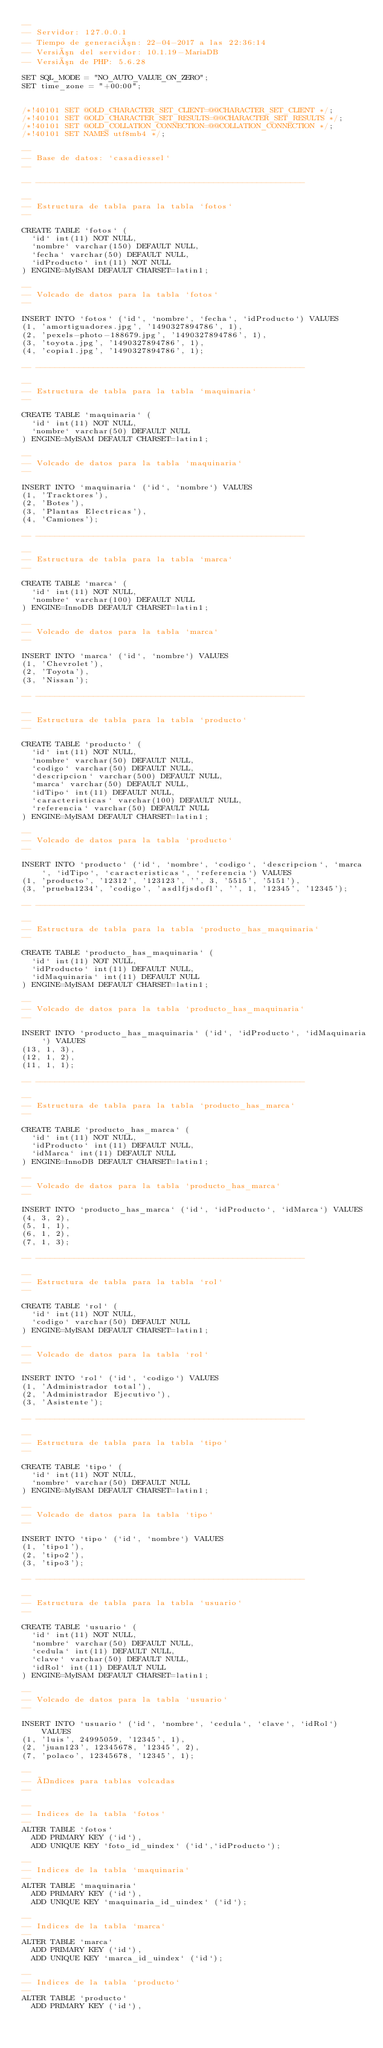<code> <loc_0><loc_0><loc_500><loc_500><_SQL_>--
-- Servidor: 127.0.0.1
-- Tiempo de generación: 22-04-2017 a las 22:36:14
-- Versión del servidor: 10.1.19-MariaDB
-- Versión de PHP: 5.6.28

SET SQL_MODE = "NO_AUTO_VALUE_ON_ZERO";
SET time_zone = "+00:00";


/*!40101 SET @OLD_CHARACTER_SET_CLIENT=@@CHARACTER_SET_CLIENT */;
/*!40101 SET @OLD_CHARACTER_SET_RESULTS=@@CHARACTER_SET_RESULTS */;
/*!40101 SET @OLD_COLLATION_CONNECTION=@@COLLATION_CONNECTION */;
/*!40101 SET NAMES utf8mb4 */;

--
-- Base de datos: `casadiessel`
--

-- --------------------------------------------------------

--
-- Estructura de tabla para la tabla `fotos`
--

CREATE TABLE `fotos` (
  `id` int(11) NOT NULL,
  `nombre` varchar(150) DEFAULT NULL,
  `fecha` varchar(50) DEFAULT NULL,
  `idProducto` int(11) NOT NULL
) ENGINE=MyISAM DEFAULT CHARSET=latin1;

--
-- Volcado de datos para la tabla `fotos`
--

INSERT INTO `fotos` (`id`, `nombre`, `fecha`, `idProducto`) VALUES
(1, 'amortiguadores.jpg', '1490327894786', 1),
(2, 'pexels-photo-188679.jpg', '1490327894786', 1),
(3, 'toyota.jpg', '1490327894786', 1),
(4, 'copia1.jpg', '1490327894786', 1);

-- --------------------------------------------------------

--
-- Estructura de tabla para la tabla `maquinaria`
--

CREATE TABLE `maquinaria` (
  `id` int(11) NOT NULL,
  `nombre` varchar(50) DEFAULT NULL
) ENGINE=MyISAM DEFAULT CHARSET=latin1;

--
-- Volcado de datos para la tabla `maquinaria`
--

INSERT INTO `maquinaria` (`id`, `nombre`) VALUES
(1, 'Tracktores'),
(2, 'Botes'),
(3, 'Plantas Electricas'),
(4, 'Camiones');

-- --------------------------------------------------------

--
-- Estructura de tabla para la tabla `marca`
--

CREATE TABLE `marca` (
  `id` int(11) NOT NULL,
  `nombre` varchar(100) DEFAULT NULL
) ENGINE=InnoDB DEFAULT CHARSET=latin1;

--
-- Volcado de datos para la tabla `marca`
--

INSERT INTO `marca` (`id`, `nombre`) VALUES
(1, 'Chevrolet'),
(2, 'Toyota'),
(3, 'Nissan');

-- --------------------------------------------------------

--
-- Estructura de tabla para la tabla `producto`
--

CREATE TABLE `producto` (
  `id` int(11) NOT NULL,
  `nombre` varchar(50) DEFAULT NULL,
  `codigo` varchar(50) DEFAULT NULL,
  `descripcion` varchar(500) DEFAULT NULL,
  `marca` varchar(50) DEFAULT NULL,
  `idTipo` int(11) DEFAULT NULL,
  `caracteristicas` varchar(100) DEFAULT NULL,
  `referencia` varchar(50) DEFAULT NULL
) ENGINE=MyISAM DEFAULT CHARSET=latin1;

--
-- Volcado de datos para la tabla `producto`
--

INSERT INTO `producto` (`id`, `nombre`, `codigo`, `descripcion`, `marca`, `idTipo`, `caracteristicas`, `referencia`) VALUES
(1, 'producto', '12312', '123123', '', 3, '5515', '5151'),
(3, 'prueba1234', 'codigo', 'asdlfjsdofl', '', 1, '12345', '12345');

-- --------------------------------------------------------

--
-- Estructura de tabla para la tabla `producto_has_maquinaria`
--

CREATE TABLE `producto_has_maquinaria` (
  `id` int(11) NOT NULL,
  `idProducto` int(11) DEFAULT NULL,
  `idMaquinaria` int(11) DEFAULT NULL
) ENGINE=MyISAM DEFAULT CHARSET=latin1;

--
-- Volcado de datos para la tabla `producto_has_maquinaria`
--

INSERT INTO `producto_has_maquinaria` (`id`, `idProducto`, `idMaquinaria`) VALUES
(13, 1, 3),
(12, 1, 2),
(11, 1, 1);

-- --------------------------------------------------------

--
-- Estructura de tabla para la tabla `producto_has_marca`
--

CREATE TABLE `producto_has_marca` (
  `id` int(11) NOT NULL,
  `idProducto` int(11) DEFAULT NULL,
  `idMarca` int(11) DEFAULT NULL
) ENGINE=InnoDB DEFAULT CHARSET=latin1;

--
-- Volcado de datos para la tabla `producto_has_marca`
--

INSERT INTO `producto_has_marca` (`id`, `idProducto`, `idMarca`) VALUES
(4, 3, 2),
(5, 1, 1),
(6, 1, 2),
(7, 1, 3);

-- --------------------------------------------------------

--
-- Estructura de tabla para la tabla `rol`
--

CREATE TABLE `rol` (
  `id` int(11) NOT NULL,
  `codigo` varchar(50) DEFAULT NULL
) ENGINE=MyISAM DEFAULT CHARSET=latin1;

--
-- Volcado de datos para la tabla `rol`
--

INSERT INTO `rol` (`id`, `codigo`) VALUES
(1, 'Administrador total'),
(2, 'Administrador Ejecutivo'),
(3, 'Asistente');

-- --------------------------------------------------------

--
-- Estructura de tabla para la tabla `tipo`
--

CREATE TABLE `tipo` (
  `id` int(11) NOT NULL,
  `nombre` varchar(50) DEFAULT NULL
) ENGINE=MyISAM DEFAULT CHARSET=latin1;

--
-- Volcado de datos para la tabla `tipo`
--

INSERT INTO `tipo` (`id`, `nombre`) VALUES
(1, 'tipo1'),
(2, 'tipo2'),
(3, 'tipo3');

-- --------------------------------------------------------

--
-- Estructura de tabla para la tabla `usuario`
--

CREATE TABLE `usuario` (
  `id` int(11) NOT NULL,
  `nombre` varchar(50) DEFAULT NULL,
  `cedula` int(11) DEFAULT NULL,
  `clave` varchar(50) DEFAULT NULL,
  `idRol` int(11) DEFAULT NULL
) ENGINE=MyISAM DEFAULT CHARSET=latin1;

--
-- Volcado de datos para la tabla `usuario`
--

INSERT INTO `usuario` (`id`, `nombre`, `cedula`, `clave`, `idRol`) VALUES
(1, 'luis', 24995059, '12345', 1),
(2, 'juan123', 12345678, '12345', 2),
(7, 'polaco', 12345678, '12345', 1);

--
-- Índices para tablas volcadas
--

--
-- Indices de la tabla `fotos`
--
ALTER TABLE `fotos`
  ADD PRIMARY KEY (`id`),
  ADD UNIQUE KEY `foto_id_uindex` (`id`,`idProducto`);

--
-- Indices de la tabla `maquinaria`
--
ALTER TABLE `maquinaria`
  ADD PRIMARY KEY (`id`),
  ADD UNIQUE KEY `maquinaria_id_uindex` (`id`);

--
-- Indices de la tabla `marca`
--
ALTER TABLE `marca`
  ADD PRIMARY KEY (`id`),
  ADD UNIQUE KEY `marca_id_uindex` (`id`);

--
-- Indices de la tabla `producto`
--
ALTER TABLE `producto`
  ADD PRIMARY KEY (`id`),</code> 